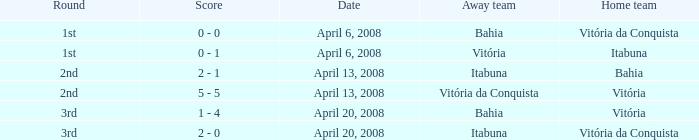Who played as the home team when Vitória was the away team? Itabuna. 